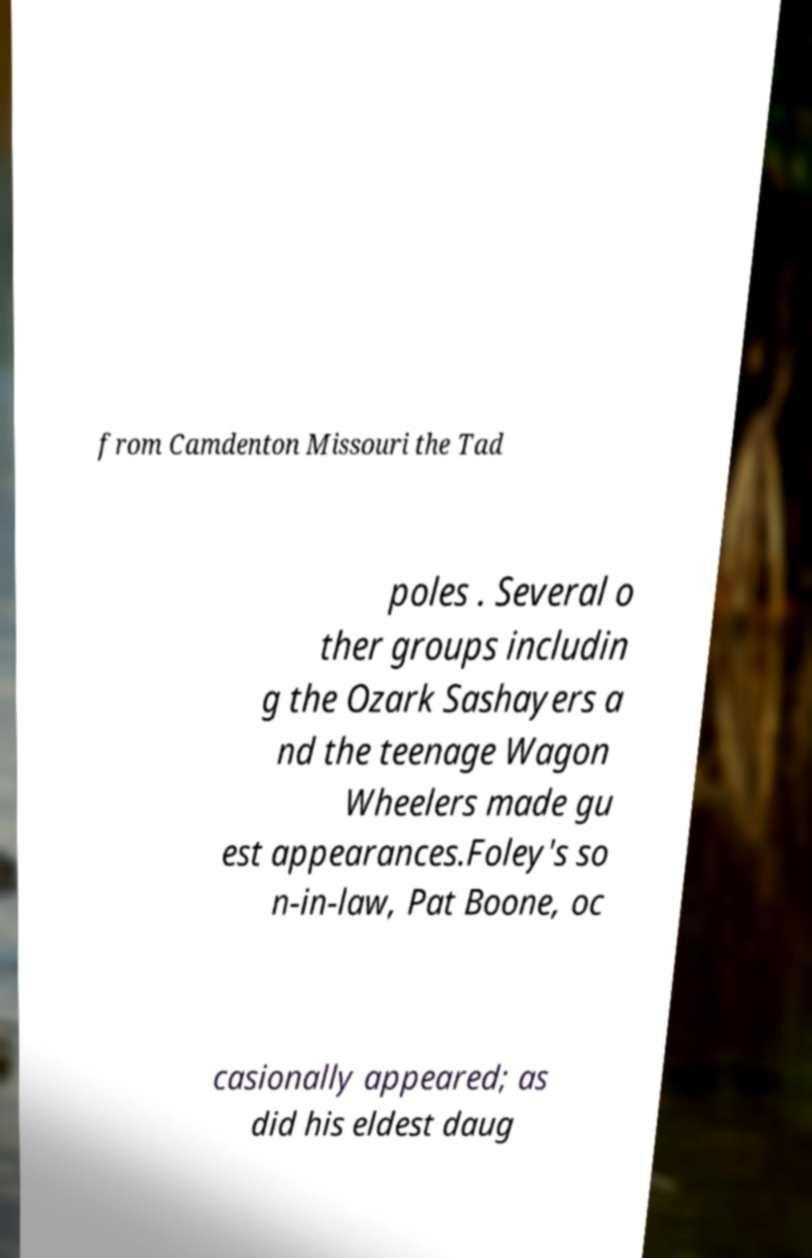Please read and relay the text visible in this image. What does it say? from Camdenton Missouri the Tad poles . Several o ther groups includin g the Ozark Sashayers a nd the teenage Wagon Wheelers made gu est appearances.Foley's so n-in-law, Pat Boone, oc casionally appeared; as did his eldest daug 